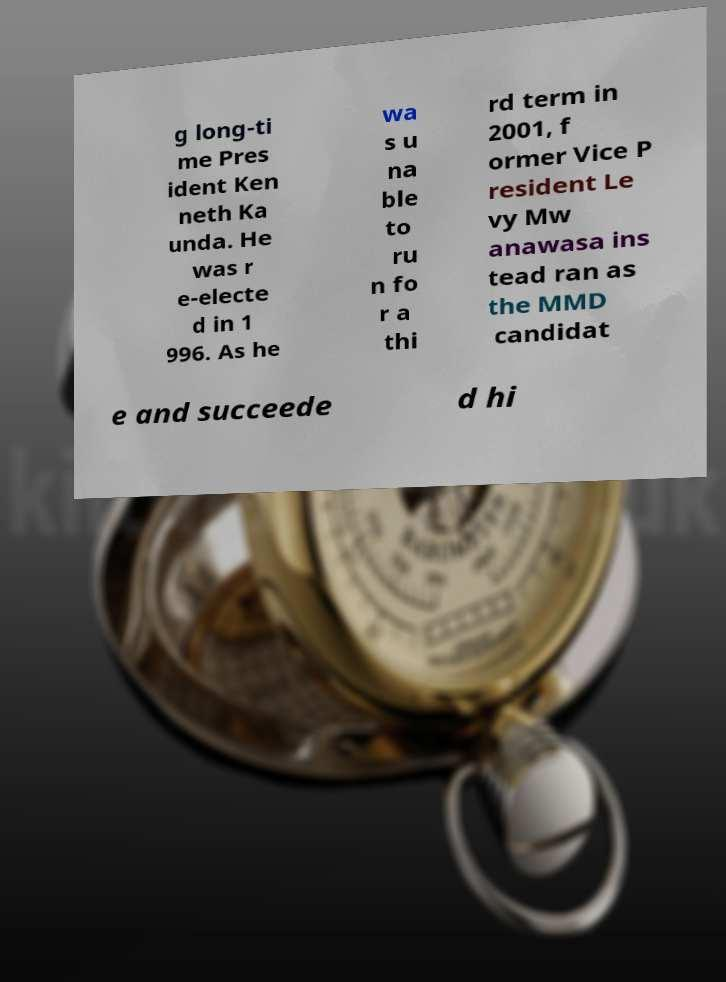Please read and relay the text visible in this image. What does it say? g long-ti me Pres ident Ken neth Ka unda. He was r e-electe d in 1 996. As he wa s u na ble to ru n fo r a thi rd term in 2001, f ormer Vice P resident Le vy Mw anawasa ins tead ran as the MMD candidat e and succeede d hi 